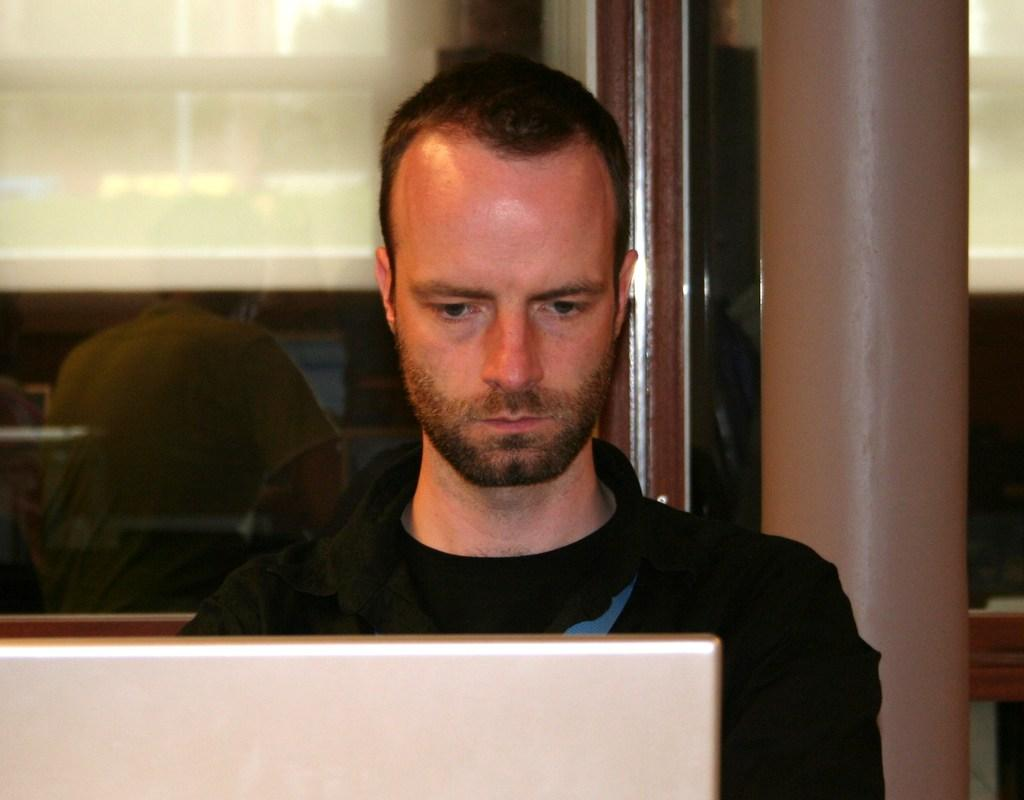What is the person in the image doing while sitting on the chair? The person is using a laptop. Can you describe the position of the person in the image? The person is sitting on a chair. Is there anyone else visible in the image? Yes, there is another person visible in the background of the image, but only from the backside. What type of knot is the person tying in the image? There is no knot present in the image; the person is using a laptop. How many grandmothers can be seen in the image? There is no grandmother present in the image. 